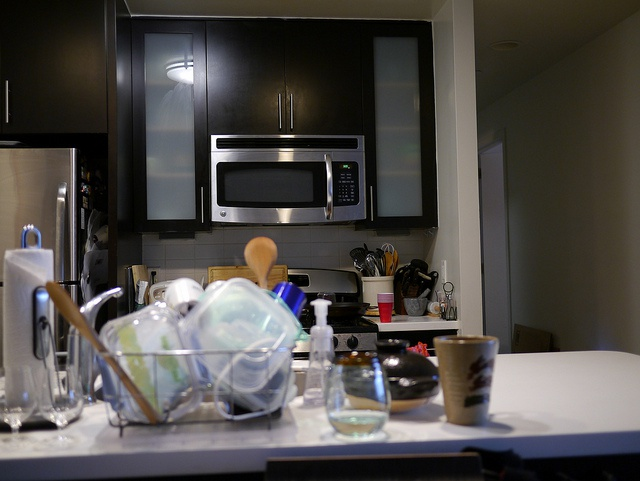Describe the objects in this image and their specific colors. I can see dining table in black, darkgray, gray, and lightgray tones, microwave in black, gray, lightgray, and darkgray tones, refrigerator in black and gray tones, bowl in black, lightgray, and darkgray tones, and cup in black, darkgray, gray, and lightgray tones in this image. 